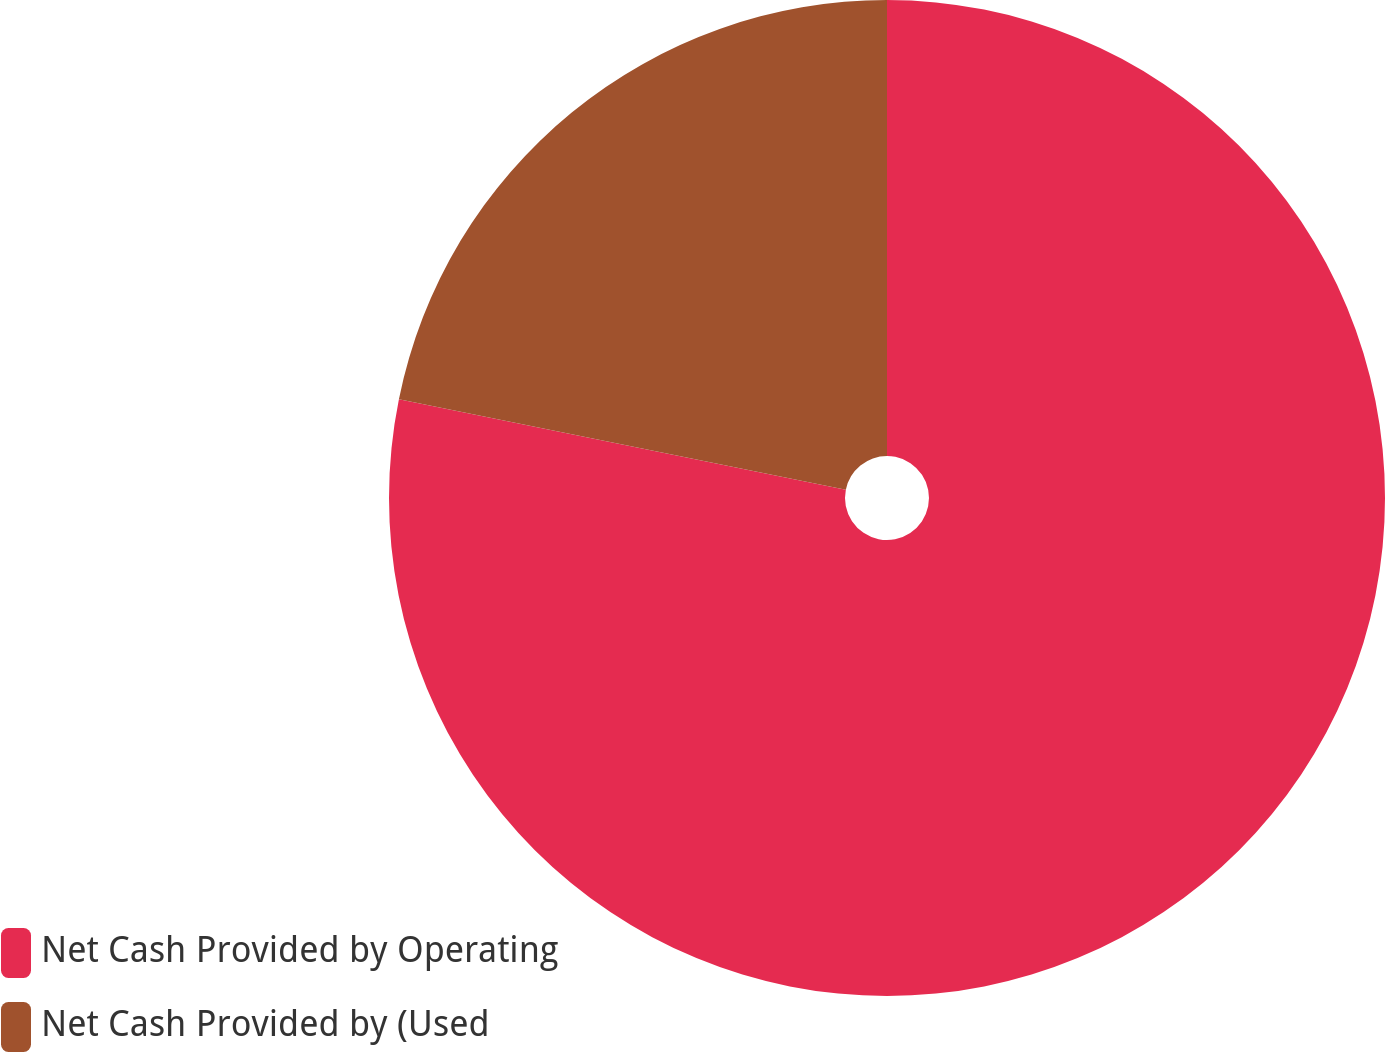Convert chart. <chart><loc_0><loc_0><loc_500><loc_500><pie_chart><fcel>Net Cash Provided by Operating<fcel>Net Cash Provided by (Used<nl><fcel>78.18%<fcel>21.82%<nl></chart> 